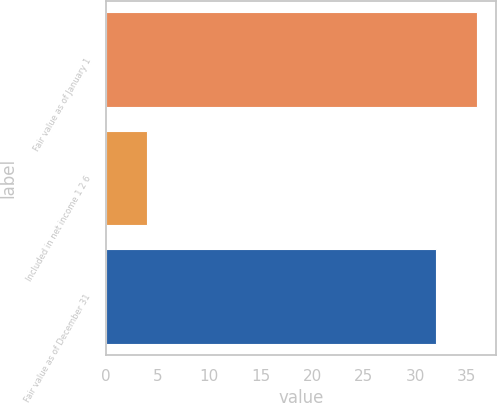Convert chart to OTSL. <chart><loc_0><loc_0><loc_500><loc_500><bar_chart><fcel>Fair value as of January 1<fcel>Included in net income 1 2 6<fcel>Fair value as of December 31<nl><fcel>36<fcel>4<fcel>32<nl></chart> 